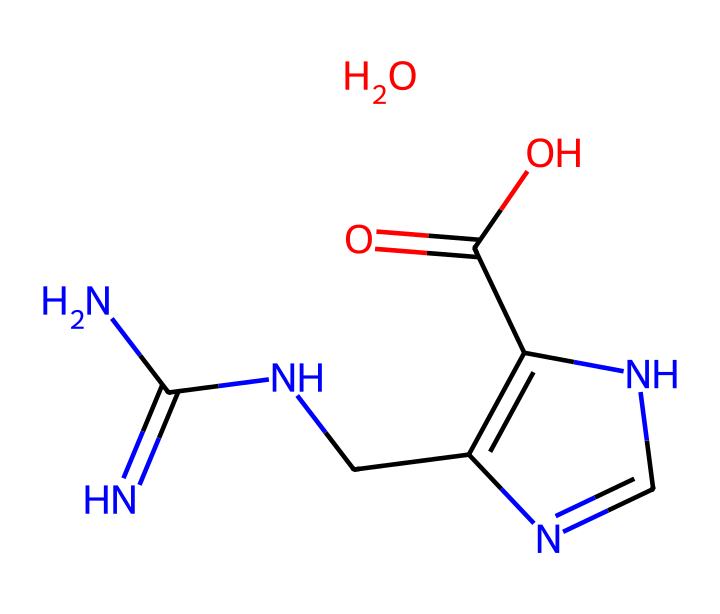What is the total number of nitrogen atoms in the chemical? By analyzing the SMILES representation, we can count the nitrogen atoms present. There are three 'N' characters indicating three nitrogen atoms in the structure.
Answer: three How many total atoms are present in this chemical structure? The SMILES representation can be unpacked to identify each element: carbon (C), hydrogen (H), nitrogen (N), and oxygen (O). By counting, we sum up the total: 5 Carbon, 10 Hydrogen, 3 Nitrogen, and 2 Oxygen atoms, which equals 20 atoms in total.
Answer: twenty What is the primary functional group in this chemical structure? By examining the SMILES, we can identify the presence of an amine (NH2) and the carboxylic acid (-COOH) functional groups. However, considering the hydrazine context, the amine group is particularly noteworthy.
Answer: amine What is the molecular weight of this compound? By calculating the molecular weight using the atoms (C: 5*12.01 + H: 10*1.008 + N: 3*14.01 + O: 2*16.00), we find the molecular weight to be approximately 175.17 grams per mole.
Answer: 175.17 grams per mole Is this compound a hydrazine derivative? Identifying the key components, we note that hydrazines include nitrogen and have a structure that contains -N-N- linkages, which are present here, making it a derivative.
Answer: yes Does this chemical have any chiral centers? Evaluating the structure for chiral centers involves checking for carbon atoms that have four different substituents. This compound has no carbon atom meeting that criterion, indicating there are no chiral centers.
Answer: no What type of bonding is predominantly present in hydrazines? The structure contains primarily covalent bonds formed between nitrogen, carbon, and oxygen atoms, characteristic of hydrazines due to their molecular interactions.
Answer: covalent 